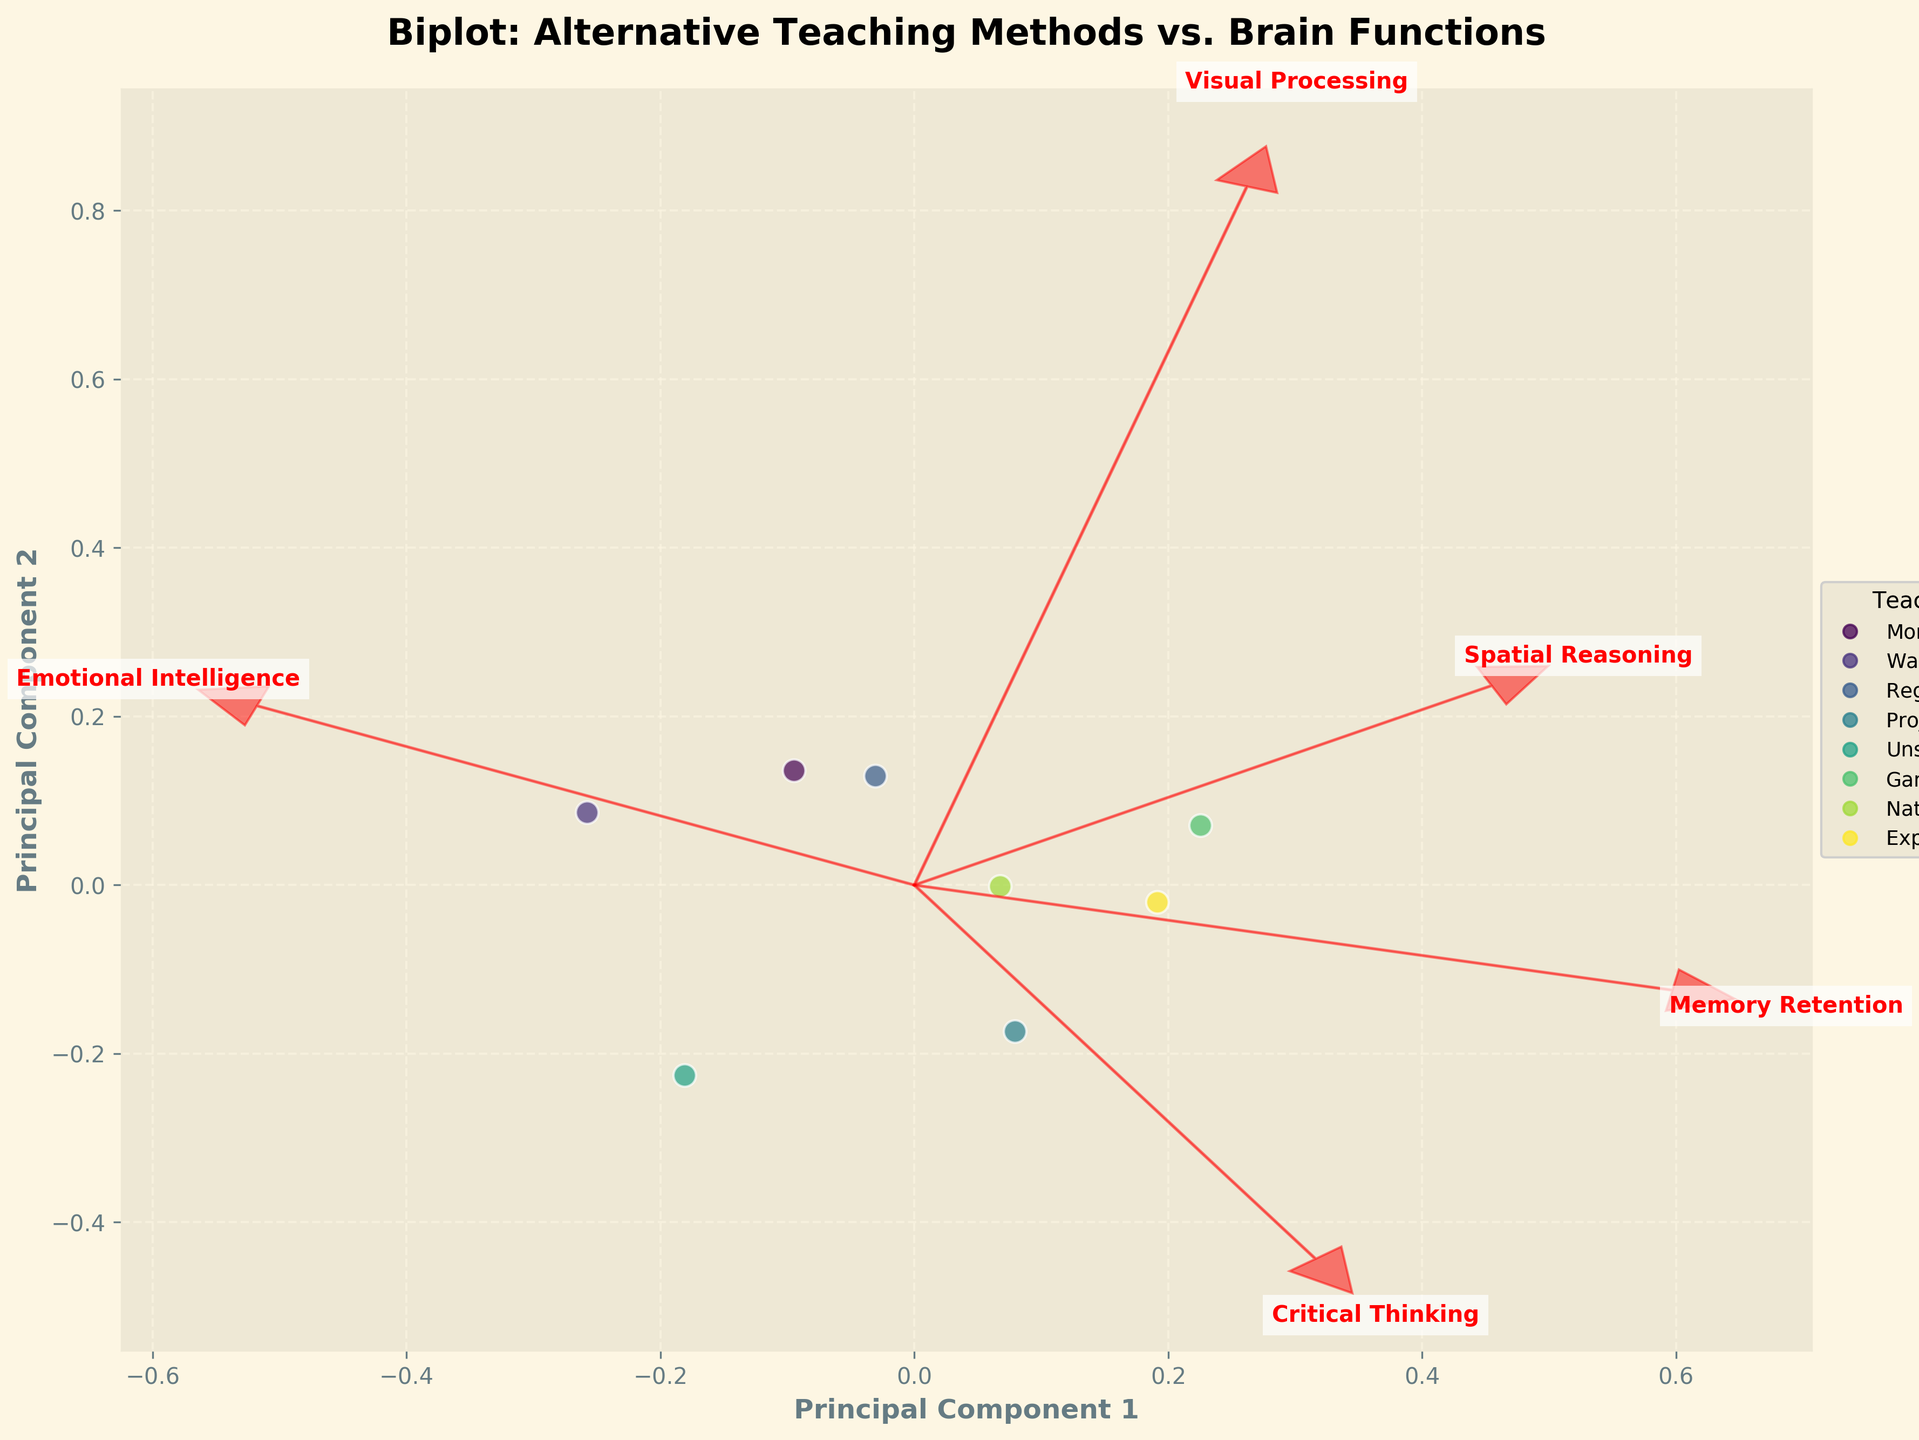What is the title of the plot? The title is written at the top of the plot. It describes the contents and purpose of the figure.
Answer: Biplot: Alternative Teaching Methods vs. Brain Functions How many teaching methods are depicted in the plot? Count the number of unique data points or scatter markers on the plot, each representing a different teaching method.
Answer: 8 What do the arrows represent in the biplot? The arrows indicate the direction and magnitude of each brain function variable in the PCA-transformed coordinate system. They help show how each brain function contributes to the separation of the teaching methods.
Answer: Brain function variables Which brain function is most strongly correlated with Principal Component 1? Determine which arrow has the longest projection along the Principal Component 1 axis, suggesting strongest correlation.
Answer: Visual Processing How do Montessori and Waldorf compare in Principal Component 2? Look at the positions of Montessori and Waldorf along the Principal Component 2 axis. Compare their relative heights.
Answer: Montessori is higher Which teaching method is closest to Project-Based Learning on the plot? Identify the position of Project-Based Learning and find the teaching method located nearest to it.
Answer: Experiential Learning Which brain functions have vectors pointing in similar directions? Analyze the directions of the arrows representing each brain function and find those that align closely.
Answer: Spatial Reasoning & Visual Processing Which teaching method has the highest score on Principal Component 2? Identify the data point with the highest value along the Principal Component 2 axis.
Answer: Project-Based Learning What can be inferred about Gamification and Memory Retention? Observe the direction and magnitude of the Memory Retention arrow in relation to the position of Gamification.
Answer: Strong positive relationship If you combine Critical Thinking and Emotional Intelligence, which teaching method benefits the most? Adding the contributions along the relevant arrows, identify the teaching method situated in the combined direction of these brain functions.
Answer: Experiential Learning 